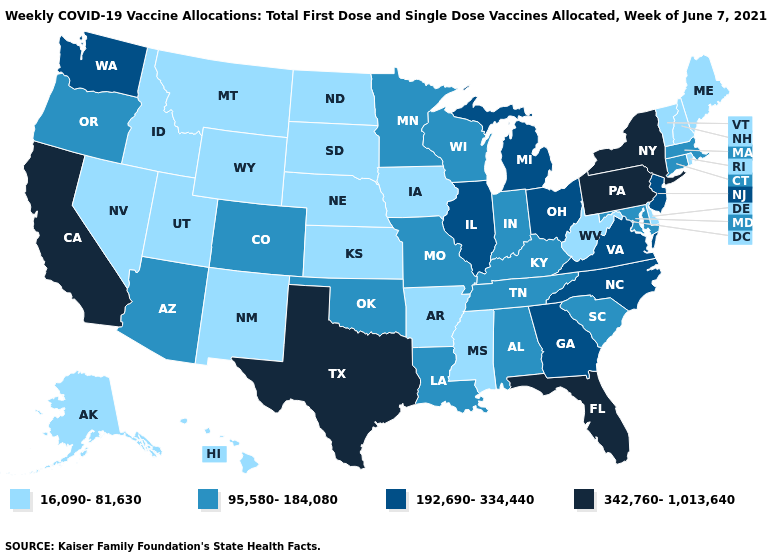Name the states that have a value in the range 342,760-1,013,640?
Keep it brief. California, Florida, New York, Pennsylvania, Texas. How many symbols are there in the legend?
Answer briefly. 4. Does South Dakota have the lowest value in the USA?
Be succinct. Yes. What is the value of Texas?
Short answer required. 342,760-1,013,640. Does New Hampshire have the same value as Texas?
Be succinct. No. What is the value of Arkansas?
Give a very brief answer. 16,090-81,630. Which states have the lowest value in the USA?
Concise answer only. Alaska, Arkansas, Delaware, Hawaii, Idaho, Iowa, Kansas, Maine, Mississippi, Montana, Nebraska, Nevada, New Hampshire, New Mexico, North Dakota, Rhode Island, South Dakota, Utah, Vermont, West Virginia, Wyoming. Among the states that border North Carolina , which have the lowest value?
Short answer required. South Carolina, Tennessee. Name the states that have a value in the range 16,090-81,630?
Answer briefly. Alaska, Arkansas, Delaware, Hawaii, Idaho, Iowa, Kansas, Maine, Mississippi, Montana, Nebraska, Nevada, New Hampshire, New Mexico, North Dakota, Rhode Island, South Dakota, Utah, Vermont, West Virginia, Wyoming. Among the states that border New York , does Vermont have the lowest value?
Write a very short answer. Yes. What is the lowest value in states that border Rhode Island?
Answer briefly. 95,580-184,080. What is the value of Massachusetts?
Be succinct. 95,580-184,080. Does Ohio have the lowest value in the MidWest?
Be succinct. No. Which states have the lowest value in the USA?
Write a very short answer. Alaska, Arkansas, Delaware, Hawaii, Idaho, Iowa, Kansas, Maine, Mississippi, Montana, Nebraska, Nevada, New Hampshire, New Mexico, North Dakota, Rhode Island, South Dakota, Utah, Vermont, West Virginia, Wyoming. Name the states that have a value in the range 95,580-184,080?
Concise answer only. Alabama, Arizona, Colorado, Connecticut, Indiana, Kentucky, Louisiana, Maryland, Massachusetts, Minnesota, Missouri, Oklahoma, Oregon, South Carolina, Tennessee, Wisconsin. 